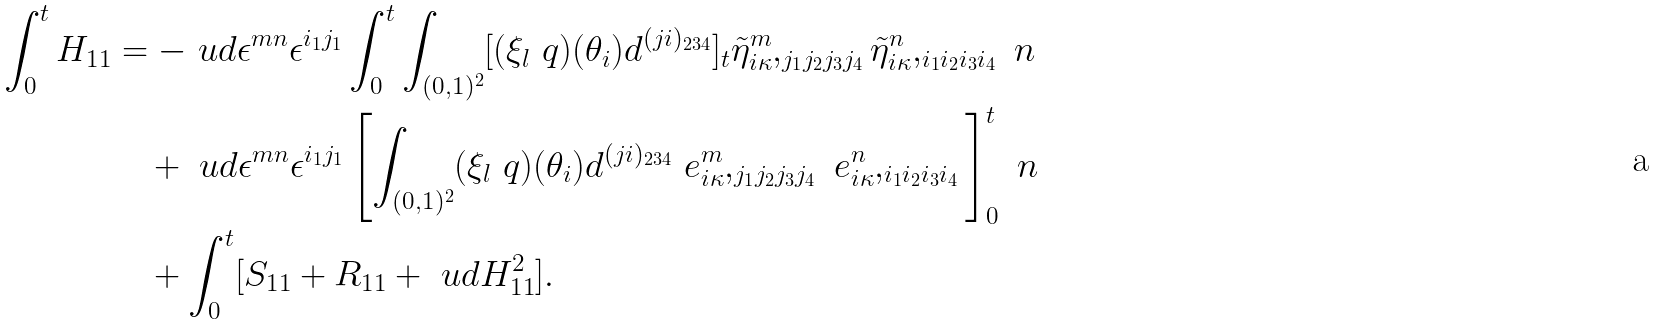<formula> <loc_0><loc_0><loc_500><loc_500>\int _ { 0 } ^ { t } H _ { 1 1 } & = - \ u d \epsilon ^ { m n } \epsilon ^ { i _ { 1 } j _ { 1 } } \int _ { 0 } ^ { t } \int _ { ( 0 , 1 ) ^ { 2 } } [ ( \xi _ { l } \ q ) ( \theta _ { i } ) d ^ { ( j i ) _ { 2 3 4 } } ] _ { t } \tilde { \eta } _ { i \kappa } ^ { m } , _ { j _ { 1 } j _ { 2 } j _ { 3 } j _ { 4 } } \tilde { \eta } _ { i \kappa } ^ { n } , _ { i _ { 1 } i _ { 2 } i _ { 3 } i _ { 4 } } \ n \\ & \quad + \ u d \epsilon ^ { m n } \epsilon ^ { i _ { 1 } j _ { 1 } } \left [ \int _ { ( 0 , 1 ) ^ { 2 } } ( \xi _ { l } \ q ) ( \theta _ { i } ) d ^ { ( j i ) _ { 2 3 4 } } \ e _ { i \kappa } ^ { m } , _ { j _ { 1 } j _ { 2 } j _ { 3 } j _ { 4 } } \ e _ { i \kappa } ^ { n } , _ { i _ { 1 } i _ { 2 } i _ { 3 } i _ { 4 } } \right ] _ { 0 } ^ { t } \ n \\ & \quad + \int _ { 0 } ^ { t } [ S _ { 1 1 } + R _ { 1 1 } + \ u d H _ { 1 1 } ^ { 2 } ] .</formula> 